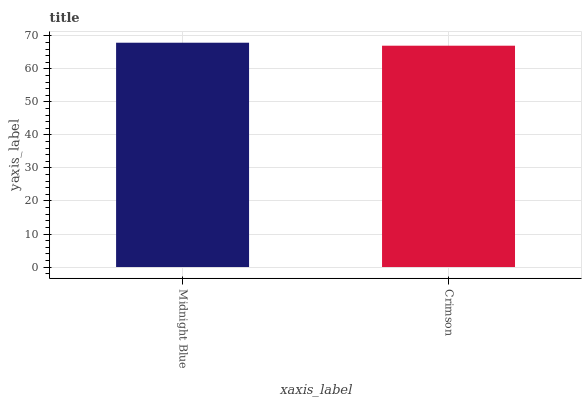Is Crimson the minimum?
Answer yes or no. Yes. Is Midnight Blue the maximum?
Answer yes or no. Yes. Is Crimson the maximum?
Answer yes or no. No. Is Midnight Blue greater than Crimson?
Answer yes or no. Yes. Is Crimson less than Midnight Blue?
Answer yes or no. Yes. Is Crimson greater than Midnight Blue?
Answer yes or no. No. Is Midnight Blue less than Crimson?
Answer yes or no. No. Is Midnight Blue the high median?
Answer yes or no. Yes. Is Crimson the low median?
Answer yes or no. Yes. Is Crimson the high median?
Answer yes or no. No. Is Midnight Blue the low median?
Answer yes or no. No. 